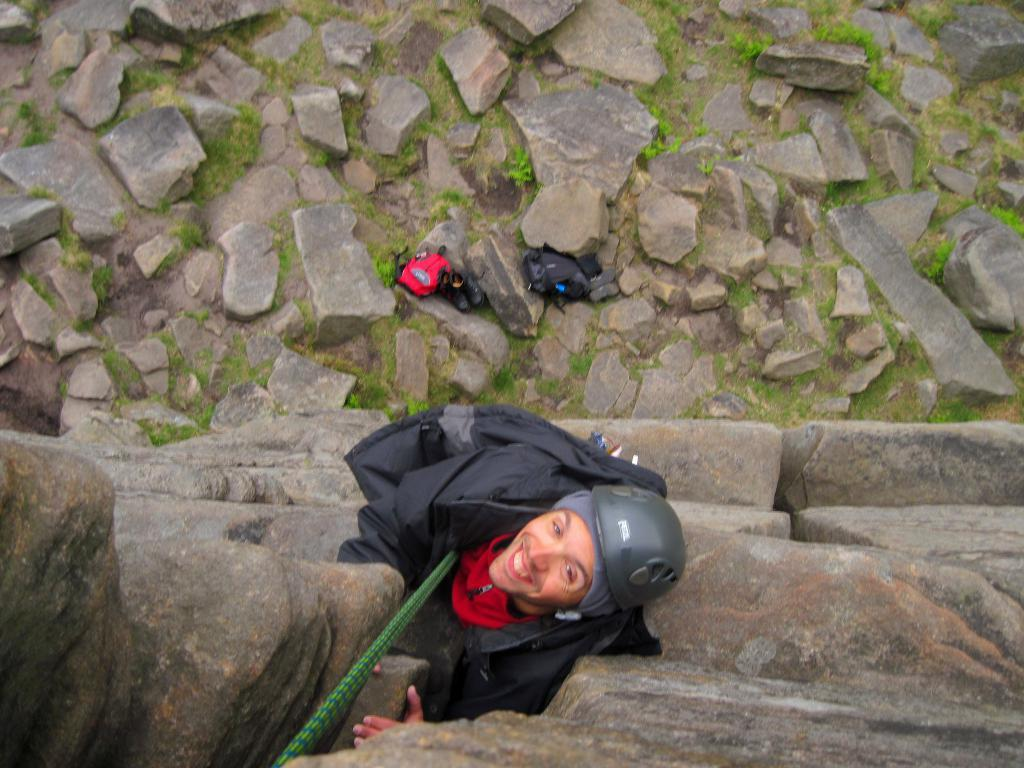What is the person in the image doing? The person is climbing rocks in the image. How is the person assisted in climbing the rocks? The person is using a rope for assistance. What can be seen below the person while they are climbing? There are rocks visible below the person. What type of vegetation is present in the image? There is grass in the image. What items can be seen in the image that might belong to the person climbing? There are bags and shoes in the image. What type of eggs can be seen flowing in the current in the image? There are no eggs or current present in the image; it features a person climbing rocks with a rope. 